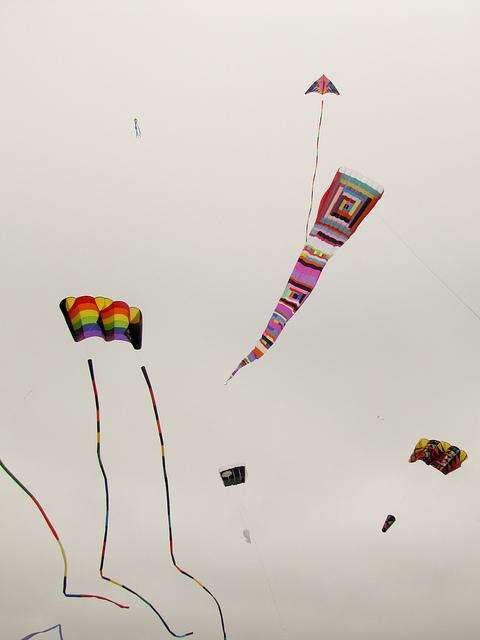What is rising in the air?

Choices:
A) airplane
B) balloon
C) kite
D) butterfly kite 